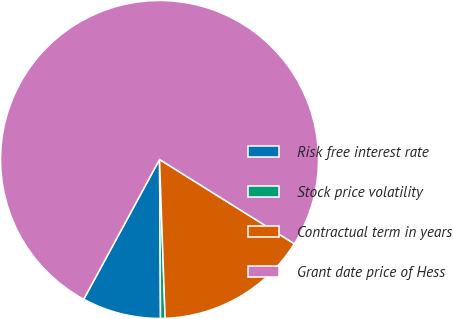<chart> <loc_0><loc_0><loc_500><loc_500><pie_chart><fcel>Risk free interest rate<fcel>Stock price volatility<fcel>Contractual term in years<fcel>Grant date price of Hess<nl><fcel>8.01%<fcel>0.46%<fcel>15.55%<fcel>75.98%<nl></chart> 